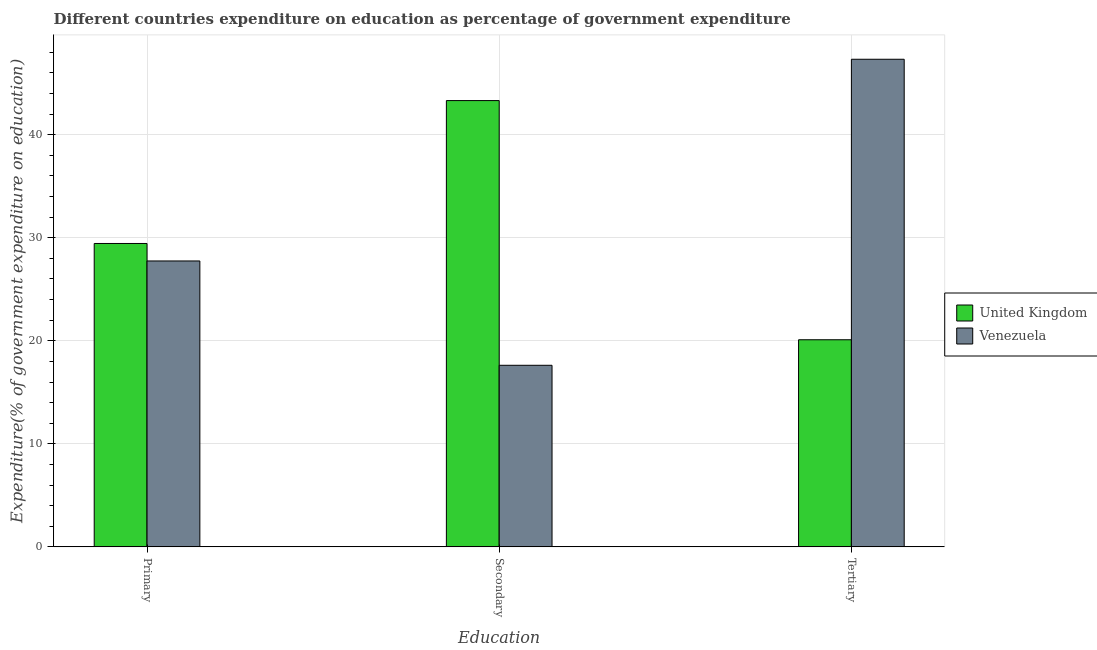Are the number of bars per tick equal to the number of legend labels?
Make the answer very short. Yes. Are the number of bars on each tick of the X-axis equal?
Ensure brevity in your answer.  Yes. How many bars are there on the 2nd tick from the left?
Ensure brevity in your answer.  2. What is the label of the 2nd group of bars from the left?
Offer a very short reply. Secondary. What is the expenditure on secondary education in Venezuela?
Provide a succinct answer. 17.62. Across all countries, what is the maximum expenditure on secondary education?
Your response must be concise. 43.31. Across all countries, what is the minimum expenditure on primary education?
Provide a succinct answer. 27.75. What is the total expenditure on tertiary education in the graph?
Ensure brevity in your answer.  67.43. What is the difference between the expenditure on primary education in United Kingdom and that in Venezuela?
Offer a terse response. 1.7. What is the difference between the expenditure on tertiary education in United Kingdom and the expenditure on secondary education in Venezuela?
Keep it short and to the point. 2.48. What is the average expenditure on primary education per country?
Keep it short and to the point. 28.6. What is the difference between the expenditure on secondary education and expenditure on primary education in Venezuela?
Keep it short and to the point. -10.13. What is the ratio of the expenditure on primary education in United Kingdom to that in Venezuela?
Provide a succinct answer. 1.06. What is the difference between the highest and the second highest expenditure on primary education?
Provide a short and direct response. 1.7. What is the difference between the highest and the lowest expenditure on secondary education?
Give a very brief answer. 25.69. Is the sum of the expenditure on primary education in Venezuela and United Kingdom greater than the maximum expenditure on tertiary education across all countries?
Provide a short and direct response. Yes. What does the 2nd bar from the left in Primary represents?
Provide a short and direct response. Venezuela. What does the 1st bar from the right in Primary represents?
Ensure brevity in your answer.  Venezuela. How many bars are there?
Your answer should be compact. 6. Are all the bars in the graph horizontal?
Your answer should be very brief. No. Does the graph contain any zero values?
Offer a terse response. No. Where does the legend appear in the graph?
Provide a short and direct response. Center right. How many legend labels are there?
Give a very brief answer. 2. What is the title of the graph?
Keep it short and to the point. Different countries expenditure on education as percentage of government expenditure. Does "Malawi" appear as one of the legend labels in the graph?
Ensure brevity in your answer.  No. What is the label or title of the X-axis?
Your answer should be very brief. Education. What is the label or title of the Y-axis?
Your answer should be very brief. Expenditure(% of government expenditure on education). What is the Expenditure(% of government expenditure on education) of United Kingdom in Primary?
Your response must be concise. 29.45. What is the Expenditure(% of government expenditure on education) of Venezuela in Primary?
Keep it short and to the point. 27.75. What is the Expenditure(% of government expenditure on education) in United Kingdom in Secondary?
Your answer should be very brief. 43.31. What is the Expenditure(% of government expenditure on education) of Venezuela in Secondary?
Keep it short and to the point. 17.62. What is the Expenditure(% of government expenditure on education) of United Kingdom in Tertiary?
Your answer should be very brief. 20.1. What is the Expenditure(% of government expenditure on education) of Venezuela in Tertiary?
Your answer should be compact. 47.33. Across all Education, what is the maximum Expenditure(% of government expenditure on education) of United Kingdom?
Provide a short and direct response. 43.31. Across all Education, what is the maximum Expenditure(% of government expenditure on education) of Venezuela?
Provide a short and direct response. 47.33. Across all Education, what is the minimum Expenditure(% of government expenditure on education) of United Kingdom?
Give a very brief answer. 20.1. Across all Education, what is the minimum Expenditure(% of government expenditure on education) of Venezuela?
Make the answer very short. 17.62. What is the total Expenditure(% of government expenditure on education) of United Kingdom in the graph?
Give a very brief answer. 92.86. What is the total Expenditure(% of government expenditure on education) in Venezuela in the graph?
Your response must be concise. 92.7. What is the difference between the Expenditure(% of government expenditure on education) in United Kingdom in Primary and that in Secondary?
Keep it short and to the point. -13.87. What is the difference between the Expenditure(% of government expenditure on education) of Venezuela in Primary and that in Secondary?
Offer a very short reply. 10.13. What is the difference between the Expenditure(% of government expenditure on education) of United Kingdom in Primary and that in Tertiary?
Your response must be concise. 9.34. What is the difference between the Expenditure(% of government expenditure on education) in Venezuela in Primary and that in Tertiary?
Your answer should be very brief. -19.58. What is the difference between the Expenditure(% of government expenditure on education) of United Kingdom in Secondary and that in Tertiary?
Your answer should be very brief. 23.21. What is the difference between the Expenditure(% of government expenditure on education) of Venezuela in Secondary and that in Tertiary?
Give a very brief answer. -29.7. What is the difference between the Expenditure(% of government expenditure on education) in United Kingdom in Primary and the Expenditure(% of government expenditure on education) in Venezuela in Secondary?
Offer a very short reply. 11.82. What is the difference between the Expenditure(% of government expenditure on education) of United Kingdom in Primary and the Expenditure(% of government expenditure on education) of Venezuela in Tertiary?
Provide a short and direct response. -17.88. What is the difference between the Expenditure(% of government expenditure on education) of United Kingdom in Secondary and the Expenditure(% of government expenditure on education) of Venezuela in Tertiary?
Your response must be concise. -4.01. What is the average Expenditure(% of government expenditure on education) of United Kingdom per Education?
Offer a very short reply. 30.95. What is the average Expenditure(% of government expenditure on education) in Venezuela per Education?
Make the answer very short. 30.9. What is the difference between the Expenditure(% of government expenditure on education) of United Kingdom and Expenditure(% of government expenditure on education) of Venezuela in Primary?
Provide a short and direct response. 1.7. What is the difference between the Expenditure(% of government expenditure on education) in United Kingdom and Expenditure(% of government expenditure on education) in Venezuela in Secondary?
Make the answer very short. 25.69. What is the difference between the Expenditure(% of government expenditure on education) in United Kingdom and Expenditure(% of government expenditure on education) in Venezuela in Tertiary?
Ensure brevity in your answer.  -27.23. What is the ratio of the Expenditure(% of government expenditure on education) of United Kingdom in Primary to that in Secondary?
Provide a succinct answer. 0.68. What is the ratio of the Expenditure(% of government expenditure on education) of Venezuela in Primary to that in Secondary?
Provide a short and direct response. 1.57. What is the ratio of the Expenditure(% of government expenditure on education) of United Kingdom in Primary to that in Tertiary?
Your answer should be compact. 1.46. What is the ratio of the Expenditure(% of government expenditure on education) in Venezuela in Primary to that in Tertiary?
Make the answer very short. 0.59. What is the ratio of the Expenditure(% of government expenditure on education) of United Kingdom in Secondary to that in Tertiary?
Your answer should be very brief. 2.15. What is the ratio of the Expenditure(% of government expenditure on education) in Venezuela in Secondary to that in Tertiary?
Your answer should be compact. 0.37. What is the difference between the highest and the second highest Expenditure(% of government expenditure on education) of United Kingdom?
Your response must be concise. 13.87. What is the difference between the highest and the second highest Expenditure(% of government expenditure on education) in Venezuela?
Provide a succinct answer. 19.58. What is the difference between the highest and the lowest Expenditure(% of government expenditure on education) in United Kingdom?
Ensure brevity in your answer.  23.21. What is the difference between the highest and the lowest Expenditure(% of government expenditure on education) of Venezuela?
Your response must be concise. 29.7. 